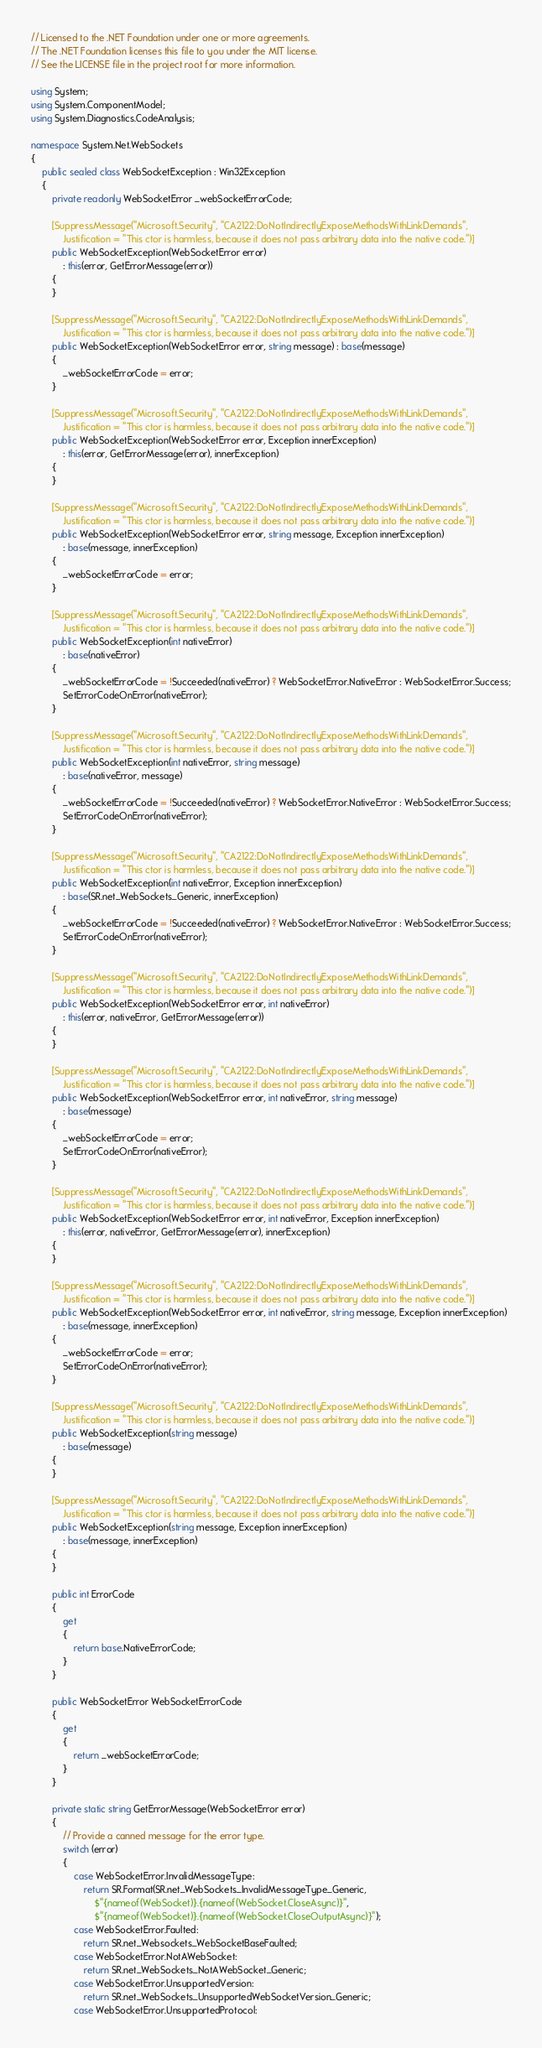Convert code to text. <code><loc_0><loc_0><loc_500><loc_500><_C#_>// Licensed to the .NET Foundation under one or more agreements.
// The .NET Foundation licenses this file to you under the MIT license.
// See the LICENSE file in the project root for more information.

using System;
using System.ComponentModel;
using System.Diagnostics.CodeAnalysis;

namespace System.Net.WebSockets
{
    public sealed class WebSocketException : Win32Exception
    {
        private readonly WebSocketError _webSocketErrorCode;

        [SuppressMessage("Microsoft.Security", "CA2122:DoNotIndirectlyExposeMethodsWithLinkDemands",
            Justification = "This ctor is harmless, because it does not pass arbitrary data into the native code.")]
        public WebSocketException(WebSocketError error)
            : this(error, GetErrorMessage(error))
        {
        }

        [SuppressMessage("Microsoft.Security", "CA2122:DoNotIndirectlyExposeMethodsWithLinkDemands",
            Justification = "This ctor is harmless, because it does not pass arbitrary data into the native code.")]
        public WebSocketException(WebSocketError error, string message) : base(message)
        {
            _webSocketErrorCode = error;
        }

        [SuppressMessage("Microsoft.Security", "CA2122:DoNotIndirectlyExposeMethodsWithLinkDemands",
            Justification = "This ctor is harmless, because it does not pass arbitrary data into the native code.")]
        public WebSocketException(WebSocketError error, Exception innerException)
            : this(error, GetErrorMessage(error), innerException)
        {
        }

        [SuppressMessage("Microsoft.Security", "CA2122:DoNotIndirectlyExposeMethodsWithLinkDemands",
            Justification = "This ctor is harmless, because it does not pass arbitrary data into the native code.")]
        public WebSocketException(WebSocketError error, string message, Exception innerException)
            : base(message, innerException)
        {
            _webSocketErrorCode = error;
        }

        [SuppressMessage("Microsoft.Security", "CA2122:DoNotIndirectlyExposeMethodsWithLinkDemands",
            Justification = "This ctor is harmless, because it does not pass arbitrary data into the native code.")]
        public WebSocketException(int nativeError)
            : base(nativeError)
        {
            _webSocketErrorCode = !Succeeded(nativeError) ? WebSocketError.NativeError : WebSocketError.Success;
            SetErrorCodeOnError(nativeError);
        }

        [SuppressMessage("Microsoft.Security", "CA2122:DoNotIndirectlyExposeMethodsWithLinkDemands",
            Justification = "This ctor is harmless, because it does not pass arbitrary data into the native code.")]
        public WebSocketException(int nativeError, string message)
            : base(nativeError, message)
        {
            _webSocketErrorCode = !Succeeded(nativeError) ? WebSocketError.NativeError : WebSocketError.Success;
            SetErrorCodeOnError(nativeError);
        }

        [SuppressMessage("Microsoft.Security", "CA2122:DoNotIndirectlyExposeMethodsWithLinkDemands",
            Justification = "This ctor is harmless, because it does not pass arbitrary data into the native code.")]
        public WebSocketException(int nativeError, Exception innerException)
            : base(SR.net_WebSockets_Generic, innerException)
        {
            _webSocketErrorCode = !Succeeded(nativeError) ? WebSocketError.NativeError : WebSocketError.Success;
            SetErrorCodeOnError(nativeError);
        }

        [SuppressMessage("Microsoft.Security", "CA2122:DoNotIndirectlyExposeMethodsWithLinkDemands",
            Justification = "This ctor is harmless, because it does not pass arbitrary data into the native code.")]
        public WebSocketException(WebSocketError error, int nativeError)
            : this(error, nativeError, GetErrorMessage(error))
        {
        }

        [SuppressMessage("Microsoft.Security", "CA2122:DoNotIndirectlyExposeMethodsWithLinkDemands",
            Justification = "This ctor is harmless, because it does not pass arbitrary data into the native code.")]
        public WebSocketException(WebSocketError error, int nativeError, string message)
            : base(message)
        {
            _webSocketErrorCode = error;
            SetErrorCodeOnError(nativeError);
        }

        [SuppressMessage("Microsoft.Security", "CA2122:DoNotIndirectlyExposeMethodsWithLinkDemands",
            Justification = "This ctor is harmless, because it does not pass arbitrary data into the native code.")]
        public WebSocketException(WebSocketError error, int nativeError, Exception innerException)
            : this(error, nativeError, GetErrorMessage(error), innerException)
        {
        }

        [SuppressMessage("Microsoft.Security", "CA2122:DoNotIndirectlyExposeMethodsWithLinkDemands",
            Justification = "This ctor is harmless, because it does not pass arbitrary data into the native code.")]
        public WebSocketException(WebSocketError error, int nativeError, string message, Exception innerException)
            : base(message, innerException)
        {
            _webSocketErrorCode = error;
            SetErrorCodeOnError(nativeError);
        }

        [SuppressMessage("Microsoft.Security", "CA2122:DoNotIndirectlyExposeMethodsWithLinkDemands",
            Justification = "This ctor is harmless, because it does not pass arbitrary data into the native code.")]
        public WebSocketException(string message)
            : base(message)
        {
        }

        [SuppressMessage("Microsoft.Security", "CA2122:DoNotIndirectlyExposeMethodsWithLinkDemands",
            Justification = "This ctor is harmless, because it does not pass arbitrary data into the native code.")]
        public WebSocketException(string message, Exception innerException)
            : base(message, innerException)
        {
        }

        public int ErrorCode
        {
            get
            {
                return base.NativeErrorCode;
            }
        }

        public WebSocketError WebSocketErrorCode
        {
            get
            {
                return _webSocketErrorCode;
            }
        }

        private static string GetErrorMessage(WebSocketError error)
        {
            // Provide a canned message for the error type.
            switch (error)
            {
                case WebSocketError.InvalidMessageType:
                    return SR.Format(SR.net_WebSockets_InvalidMessageType_Generic,
                        $"{nameof(WebSocket)}.{nameof(WebSocket.CloseAsync)}",
                        $"{nameof(WebSocket)}.{nameof(WebSocket.CloseOutputAsync)}");
                case WebSocketError.Faulted:
                    return SR.net_Websockets_WebSocketBaseFaulted;
                case WebSocketError.NotAWebSocket:
                    return SR.net_WebSockets_NotAWebSocket_Generic;
                case WebSocketError.UnsupportedVersion:
                    return SR.net_WebSockets_UnsupportedWebSocketVersion_Generic;
                case WebSocketError.UnsupportedProtocol:</code> 